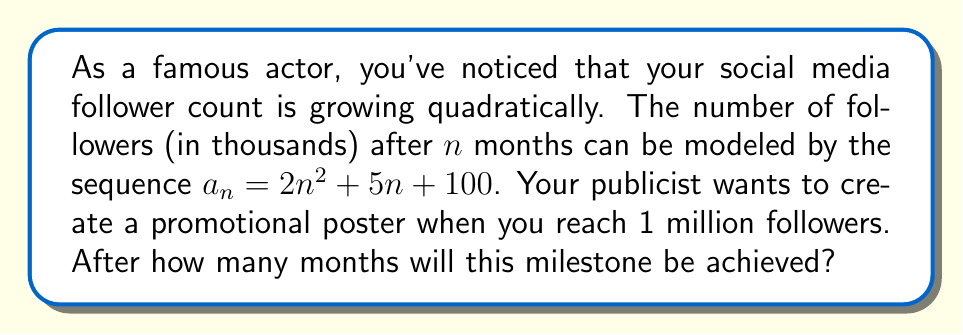What is the answer to this math problem? Let's approach this step-by-step:

1) The sequence is given by $a_n = 2n^2 + 5n + 100$, where $a_n$ represents the number of followers in thousands after $n$ months.

2) We need to find when $a_n$ reaches 1000 (as 1000 thousand = 1 million).

3) Set up the equation:
   $2n^2 + 5n + 100 = 1000$

4) Rearrange to standard quadratic form:
   $2n^2 + 5n - 900 = 0$

5) Use the quadratic formula: $n = \frac{-b \pm \sqrt{b^2 - 4ac}}{2a}$
   Where $a=2$, $b=5$, and $c=-900$

6) Substitute into the formula:
   $n = \frac{-5 \pm \sqrt{5^2 - 4(2)(-900)}}{2(2)}$

7) Simplify:
   $n = \frac{-5 \pm \sqrt{25 + 7200}}{4} = \frac{-5 \pm \sqrt{7225}}{4} = \frac{-5 \pm 85}{4}$

8) This gives us two solutions:
   $n = \frac{-5 + 85}{4} = 20$ or $n = \frac{-5 - 85}{4} = -22.5$

9) Since time cannot be negative, we discard the negative solution.

Therefore, you will reach 1 million followers after 20 months.
Answer: 20 months 